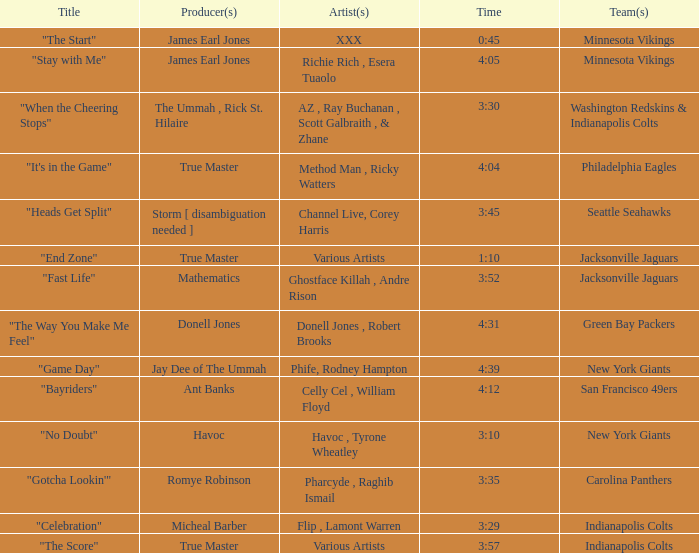Would you be able to parse every entry in this table? {'header': ['Title', 'Producer(s)', 'Artist(s)', 'Time', 'Team(s)'], 'rows': [['"The Start"', 'James Earl Jones', 'XXX', '0:45', 'Minnesota Vikings'], ['"Stay with Me"', 'James Earl Jones', 'Richie Rich , Esera Tuaolo', '4:05', 'Minnesota Vikings'], ['"When the Cheering Stops"', 'The Ummah , Rick St. Hilaire', 'AZ , Ray Buchanan , Scott Galbraith , & Zhane', '3:30', 'Washington Redskins & Indianapolis Colts'], ['"It\'s in the Game"', 'True Master', 'Method Man , Ricky Watters', '4:04', 'Philadelphia Eagles'], ['"Heads Get Split"', 'Storm [ disambiguation needed ]', 'Channel Live, Corey Harris', '3:45', 'Seattle Seahawks'], ['"End Zone"', 'True Master', 'Various Artists', '1:10', 'Jacksonville Jaguars'], ['"Fast Life"', 'Mathematics', 'Ghostface Killah , Andre Rison', '3:52', 'Jacksonville Jaguars'], ['"The Way You Make Me Feel"', 'Donell Jones', 'Donell Jones , Robert Brooks', '4:31', 'Green Bay Packers'], ['"Game Day"', 'Jay Dee of The Ummah', 'Phife, Rodney Hampton', '4:39', 'New York Giants'], ['"Bayriders"', 'Ant Banks', 'Celly Cel , William Floyd', '4:12', 'San Francisco 49ers'], ['"No Doubt"', 'Havoc', 'Havoc , Tyrone Wheatley', '3:10', 'New York Giants'], ['"Gotcha Lookin\'"', 'Romye Robinson', 'Pharcyde , Raghib Ismail', '3:35', 'Carolina Panthers'], ['"Celebration"', 'Micheal Barber', 'Flip , Lamont Warren', '3:29', 'Indianapolis Colts'], ['"The Score"', 'True Master', 'Various Artists', '3:57', 'Indianapolis Colts']]} Which artist made the track for the seattle seahawks? Channel Live, Corey Harris. 